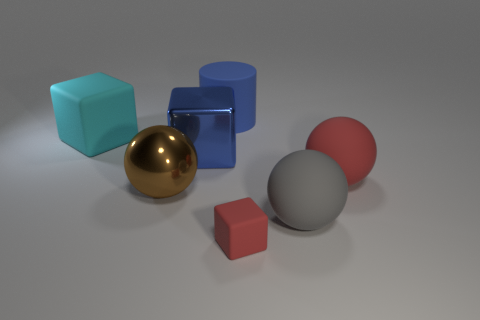Add 3 big gray rubber blocks. How many objects exist? 10 Subtract all balls. How many objects are left? 4 Subtract 0 red cylinders. How many objects are left? 7 Subtract all big blue things. Subtract all big rubber things. How many objects are left? 1 Add 7 big blue metallic objects. How many big blue metallic objects are left? 8 Add 2 big blue metallic cubes. How many big blue metallic cubes exist? 3 